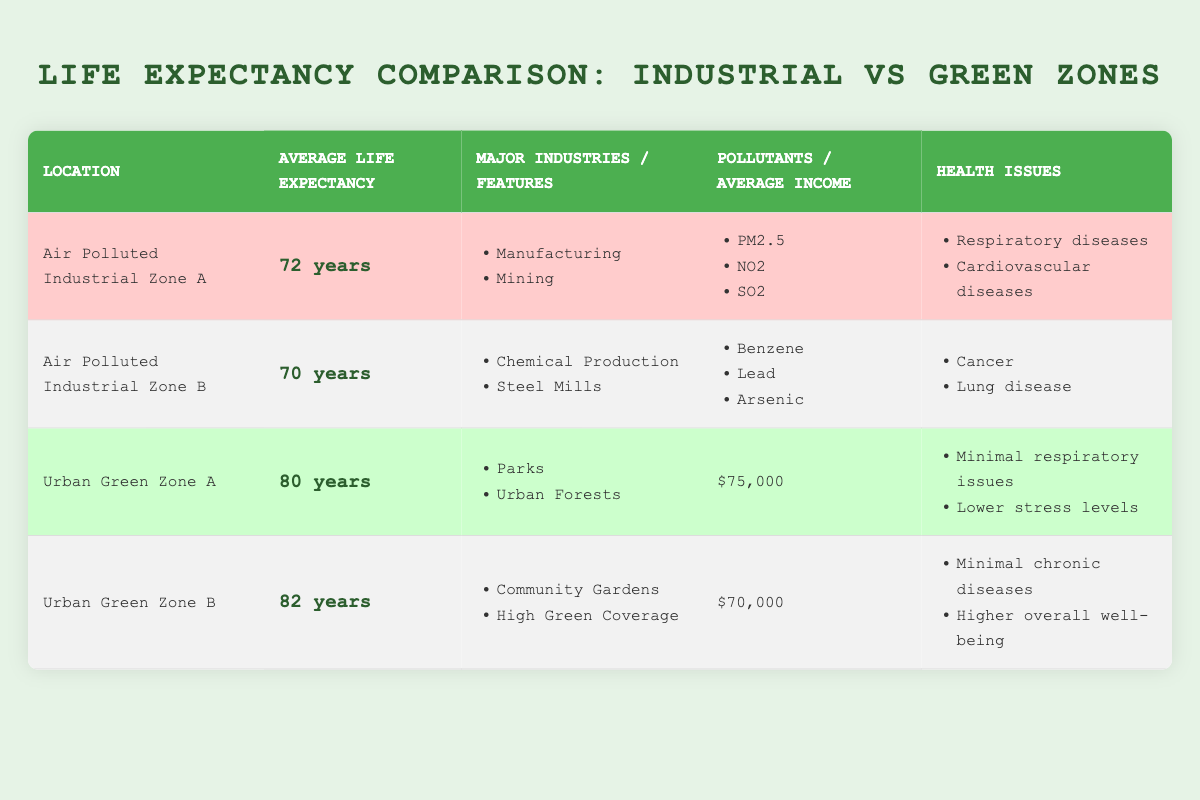What is the average life expectancy in Urban Green Zone B? The table indicates that the average life expectancy for Urban Green Zone B is 82 years. It can be found directly in the "Average Life Expectancy" column for that zone.
Answer: 82 years Which zone has a higher average life expectancy: Urban Green Zone A or Air Polluted Industrial Zone B? Urban Green Zone A has an average life expectancy of 80 years, while Air Polluted Industrial Zone B has 70 years. Since 80 is greater than 70, Urban Green Zone A has a higher average life expectancy.
Answer: Urban Green Zone A What are the major industries present in Air Polluted Industrial Zone A? The table lists "Manufacturing" and "Mining" as the major industries in Air Polluted Industrial Zone A, found in the corresponding column.
Answer: Manufacturing, Mining Are there any health issues reported in both Air Polluted Industrial Zone B and Urban Green Zone B? The health issues in Air Polluted Industrial Zone B include "Cancer" and "Lung disease," whereas Urban Green Zone B has "Minimal chronic diseases" and "Higher overall well-being." There is no overlap in health issues between the two zones, so the answer is no.
Answer: No What is the difference in average life expectancy between Urban Green Zone B and Air Polluted Industrial Zone A? Urban Green Zone B has an average life expectancy of 82 years, while Air Polluted Industrial Zone A has 72 years. To find the difference, subtract 72 from 82, which equals 10 years.
Answer: 10 years Is it true that both Green Zones show a higher average income than the Industrial Zones? Urban Green Zone A has an average income of $75,000, Urban Green Zone B has $70,000, while the Industrial Zones are not provided with an income figure. This lack of data for the Industrial Zones means it's impossible to confirm the statement, therefore the answer is false.
Answer: False What pollutants are associated with Air Polluted Industrial Zone A? The table shows that Air Polluted Industrial Zone A is associated with the pollutants "PM2.5," "NO2," and "SO2." Each pollutant is listed in the relevant column.
Answer: PM2.5, NO2, SO2 What is the total average life expectancy of both Urban Green Zones combined, and what does this imply about their quality of life compared to Industrial Zones? The average life expectancy of Urban Green Zone A is 80 years and Urban Green Zone B is 82 years. To find the total, add them: 80 + 82 = 162. Divide this by 2 to get the average for both zones: 162 / 2 = 81 years. Then compare this with the average life expectencies of Industrial Zones A (72 years) and B (70 years); both green zones have a significantly higher average life expectancy, suggesting a better quality of life due to the healthier environment.
Answer: 81 years Which location has the lowest average life expectancy? The table indicates that Air Polluted Industrial Zone B has the lowest average life expectancy at 70 years, as it is the smallest value in the "Average Life Expectancy" column.
Answer: Air Polluted Industrial Zone B 